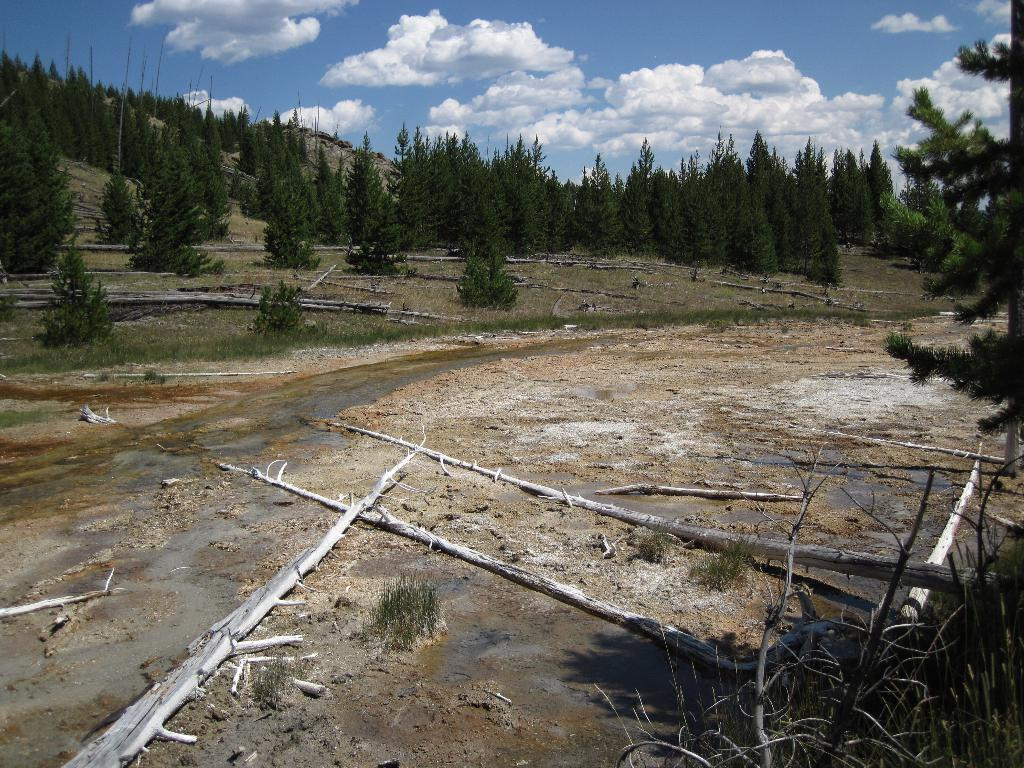What can be seen in the image that is related to nature? There are branches and trees visible in the image. What is the condition of the path in the image? There is water on the path in the image. What is visible in the background of the image? Trees are visible behind the branches in the image. What part of the natural environment is visible in the image? The sky is visible in the image. What theory is being discussed at the desk in the image? There is no desk or discussion of a theory present in the image. What act is being performed by the trees in the image? The trees are not performing any act in the image; they are simply standing in the background. 